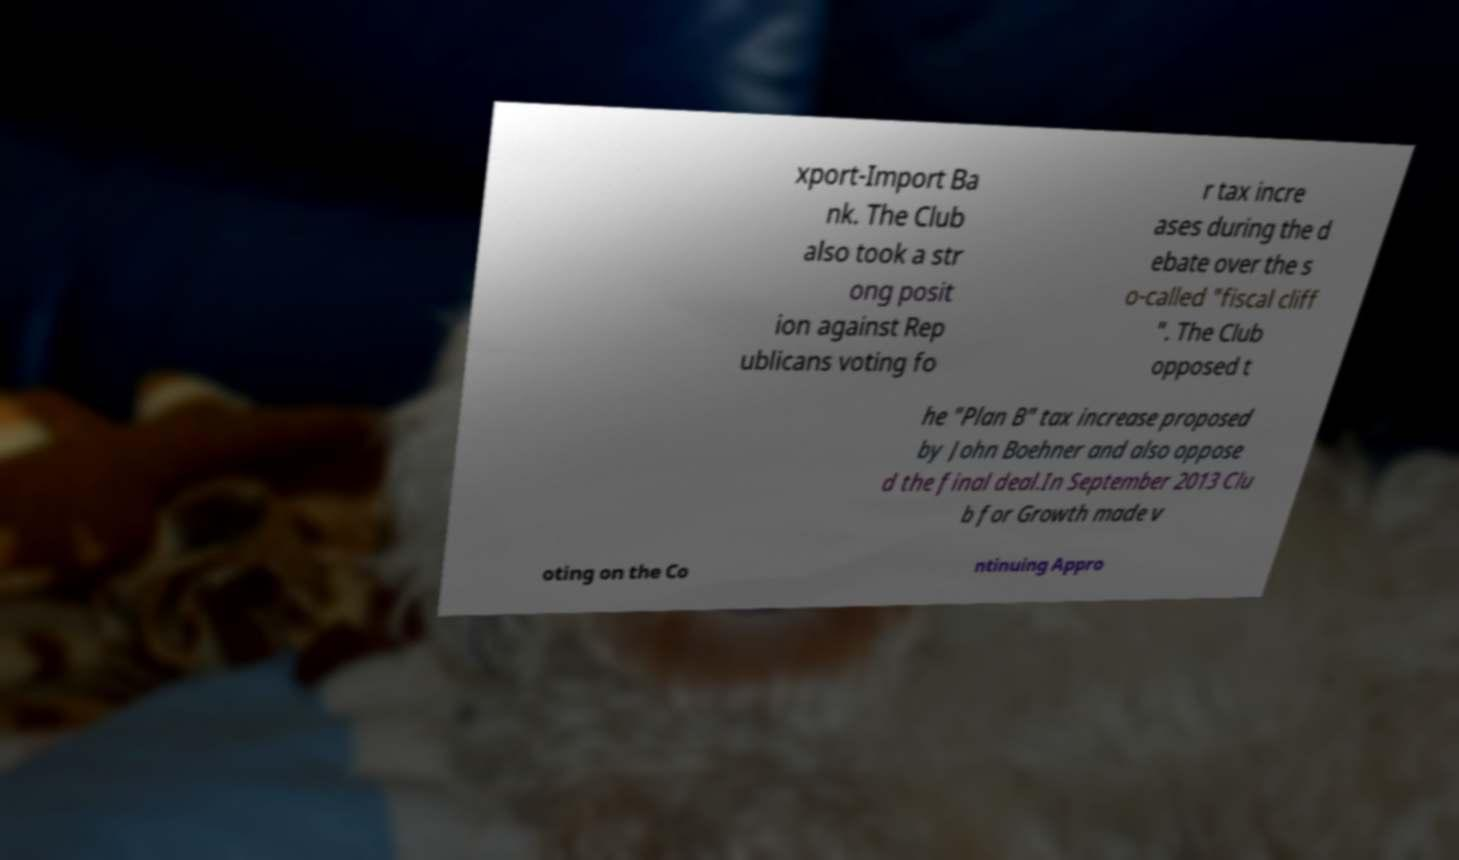Please identify and transcribe the text found in this image. xport-Import Ba nk. The Club also took a str ong posit ion against Rep ublicans voting fo r tax incre ases during the d ebate over the s o-called "fiscal cliff ". The Club opposed t he "Plan B" tax increase proposed by John Boehner and also oppose d the final deal.In September 2013 Clu b for Growth made v oting on the Co ntinuing Appro 